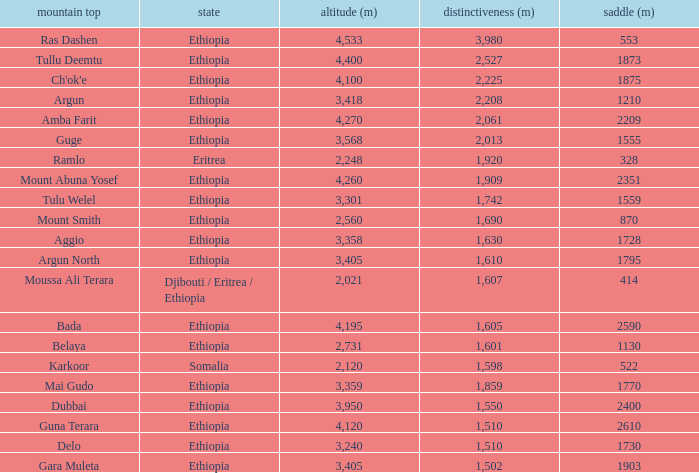What is the total prominence number in m of ethiopia, which has a col in m of 1728 and an elevation less than 3,358? 0.0. 